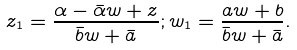Convert formula to latex. <formula><loc_0><loc_0><loc_500><loc_500>z _ { 1 } = \frac { \alpha - \bar { \alpha } w + z } { \bar { b } w + \bar { a } } ; w _ { 1 } = \frac { a w + b } { \bar { b } w + \bar { a } } .</formula> 